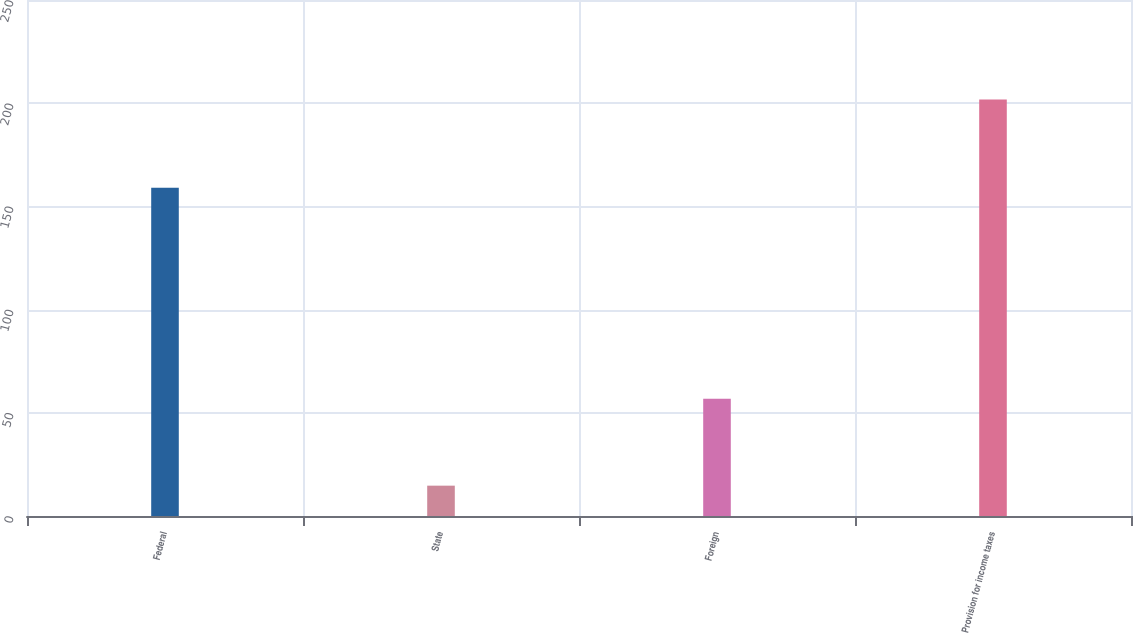Convert chart to OTSL. <chart><loc_0><loc_0><loc_500><loc_500><bar_chart><fcel>Federal<fcel>State<fcel>Foreign<fcel>Provision for income taxes<nl><fcel>159<fcel>14.7<fcel>56.8<fcel>201.8<nl></chart> 